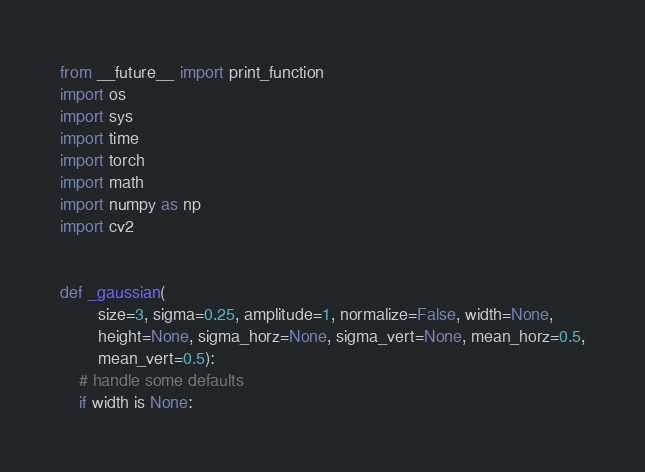<code> <loc_0><loc_0><loc_500><loc_500><_Python_>from __future__ import print_function
import os
import sys
import time
import torch
import math
import numpy as np
import cv2


def _gaussian(
        size=3, sigma=0.25, amplitude=1, normalize=False, width=None,
        height=None, sigma_horz=None, sigma_vert=None, mean_horz=0.5,
        mean_vert=0.5):
    # handle some defaults
    if width is None:</code> 